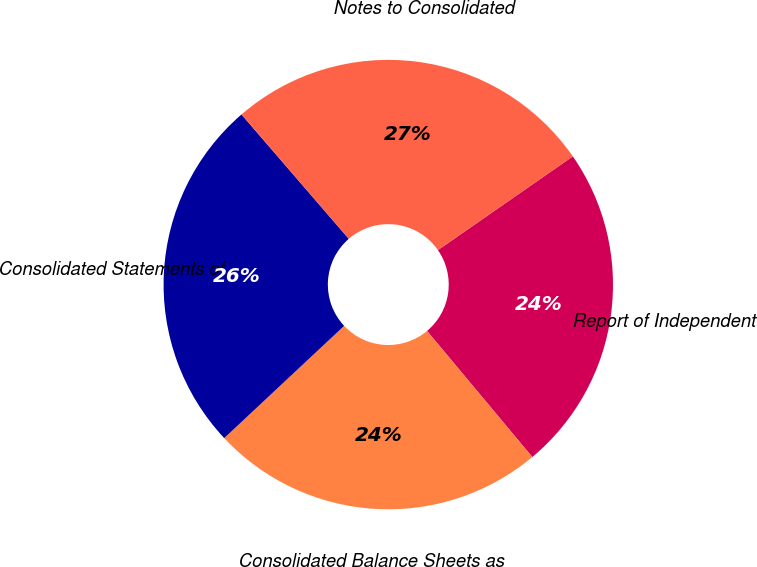Convert chart to OTSL. <chart><loc_0><loc_0><loc_500><loc_500><pie_chart><fcel>Report of Independent<fcel>Consolidated Balance Sheets as<fcel>Consolidated Statements of<fcel>Notes to Consolidated<nl><fcel>23.59%<fcel>24.1%<fcel>25.64%<fcel>26.67%<nl></chart> 